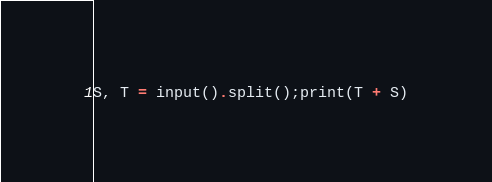Convert code to text. <code><loc_0><loc_0><loc_500><loc_500><_Python_>S, T = input().split();print(T + S)</code> 